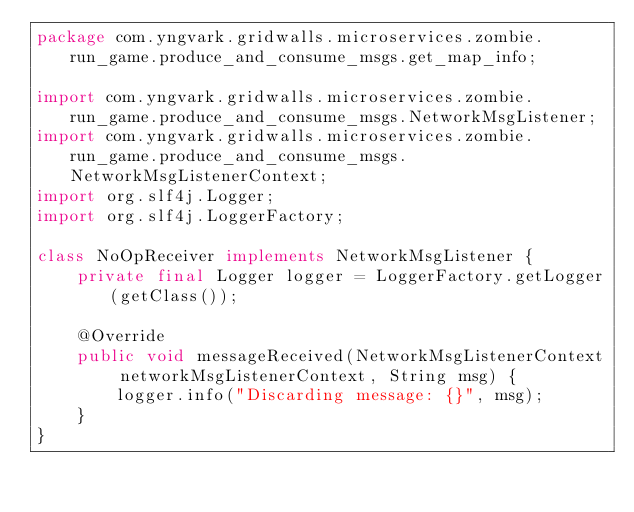Convert code to text. <code><loc_0><loc_0><loc_500><loc_500><_Java_>package com.yngvark.gridwalls.microservices.zombie.run_game.produce_and_consume_msgs.get_map_info;

import com.yngvark.gridwalls.microservices.zombie.run_game.produce_and_consume_msgs.NetworkMsgListener;
import com.yngvark.gridwalls.microservices.zombie.run_game.produce_and_consume_msgs.NetworkMsgListenerContext;
import org.slf4j.Logger;
import org.slf4j.LoggerFactory;

class NoOpReceiver implements NetworkMsgListener {
    private final Logger logger = LoggerFactory.getLogger(getClass());

    @Override
    public void messageReceived(NetworkMsgListenerContext networkMsgListenerContext, String msg) {
        logger.info("Discarding message: {}", msg);
    }
}
</code> 